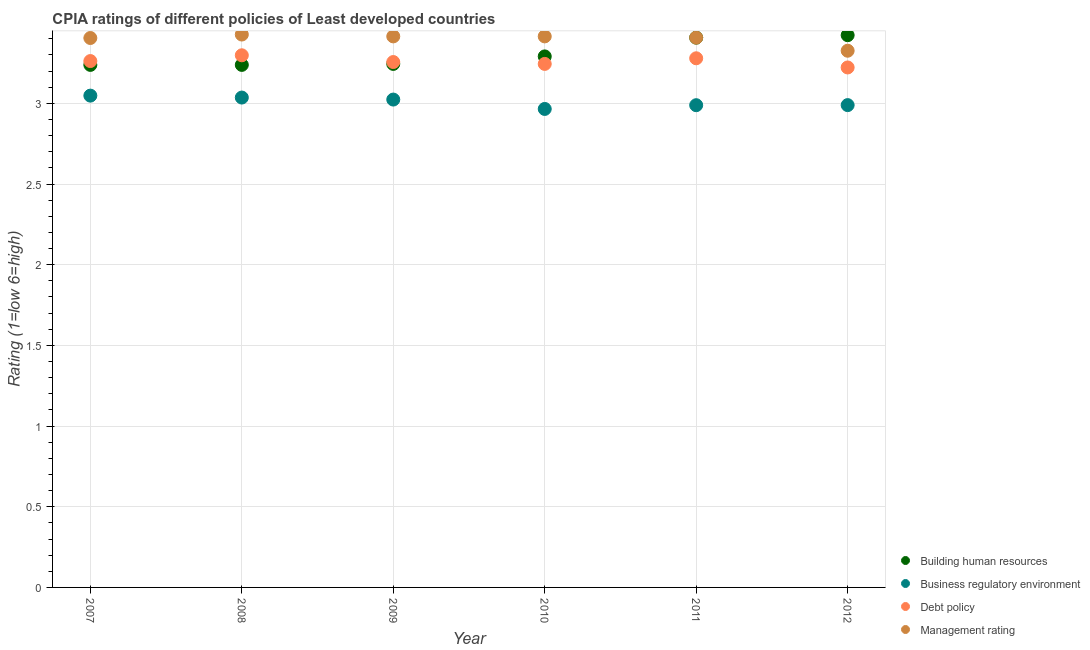How many different coloured dotlines are there?
Your answer should be very brief. 4. Is the number of dotlines equal to the number of legend labels?
Your answer should be compact. Yes. What is the cpia rating of debt policy in 2008?
Offer a very short reply. 3.3. Across all years, what is the maximum cpia rating of management?
Give a very brief answer. 3.43. Across all years, what is the minimum cpia rating of debt policy?
Your answer should be very brief. 3.22. In which year was the cpia rating of business regulatory environment maximum?
Give a very brief answer. 2007. What is the total cpia rating of debt policy in the graph?
Your answer should be compact. 19.56. What is the difference between the cpia rating of debt policy in 2009 and that in 2011?
Offer a very short reply. -0.02. What is the difference between the cpia rating of debt policy in 2007 and the cpia rating of business regulatory environment in 2008?
Your response must be concise. 0.23. What is the average cpia rating of building human resources per year?
Give a very brief answer. 3.31. In the year 2009, what is the difference between the cpia rating of building human resources and cpia rating of debt policy?
Keep it short and to the point. -0.01. What is the ratio of the cpia rating of debt policy in 2007 to that in 2008?
Keep it short and to the point. 0.99. Is the cpia rating of business regulatory environment in 2009 less than that in 2011?
Provide a succinct answer. No. Is the difference between the cpia rating of building human resources in 2008 and 2011 greater than the difference between the cpia rating of management in 2008 and 2011?
Ensure brevity in your answer.  No. What is the difference between the highest and the second highest cpia rating of business regulatory environment?
Ensure brevity in your answer.  0.01. What is the difference between the highest and the lowest cpia rating of building human resources?
Your answer should be compact. 0.18. Is it the case that in every year, the sum of the cpia rating of debt policy and cpia rating of building human resources is greater than the sum of cpia rating of management and cpia rating of business regulatory environment?
Your response must be concise. No. How many dotlines are there?
Make the answer very short. 4. What is the difference between two consecutive major ticks on the Y-axis?
Ensure brevity in your answer.  0.5. Are the values on the major ticks of Y-axis written in scientific E-notation?
Provide a succinct answer. No. How many legend labels are there?
Your answer should be compact. 4. What is the title of the graph?
Give a very brief answer. CPIA ratings of different policies of Least developed countries. Does "Social Assistance" appear as one of the legend labels in the graph?
Make the answer very short. No. What is the label or title of the X-axis?
Give a very brief answer. Year. What is the Rating (1=low 6=high) in Building human resources in 2007?
Ensure brevity in your answer.  3.24. What is the Rating (1=low 6=high) of Business regulatory environment in 2007?
Ensure brevity in your answer.  3.05. What is the Rating (1=low 6=high) of Debt policy in 2007?
Offer a very short reply. 3.26. What is the Rating (1=low 6=high) of Management rating in 2007?
Make the answer very short. 3.4. What is the Rating (1=low 6=high) in Building human resources in 2008?
Make the answer very short. 3.24. What is the Rating (1=low 6=high) of Business regulatory environment in 2008?
Your response must be concise. 3.04. What is the Rating (1=low 6=high) in Debt policy in 2008?
Offer a very short reply. 3.3. What is the Rating (1=low 6=high) in Management rating in 2008?
Offer a very short reply. 3.43. What is the Rating (1=low 6=high) in Building human resources in 2009?
Provide a succinct answer. 3.24. What is the Rating (1=low 6=high) of Business regulatory environment in 2009?
Provide a succinct answer. 3.02. What is the Rating (1=low 6=high) in Debt policy in 2009?
Your response must be concise. 3.26. What is the Rating (1=low 6=high) of Management rating in 2009?
Keep it short and to the point. 3.41. What is the Rating (1=low 6=high) of Building human resources in 2010?
Keep it short and to the point. 3.29. What is the Rating (1=low 6=high) of Business regulatory environment in 2010?
Provide a succinct answer. 2.97. What is the Rating (1=low 6=high) in Debt policy in 2010?
Offer a terse response. 3.24. What is the Rating (1=low 6=high) of Management rating in 2010?
Provide a short and direct response. 3.41. What is the Rating (1=low 6=high) in Building human resources in 2011?
Offer a terse response. 3.41. What is the Rating (1=low 6=high) of Business regulatory environment in 2011?
Your response must be concise. 2.99. What is the Rating (1=low 6=high) of Debt policy in 2011?
Ensure brevity in your answer.  3.28. What is the Rating (1=low 6=high) in Management rating in 2011?
Make the answer very short. 3.41. What is the Rating (1=low 6=high) in Building human resources in 2012?
Your answer should be very brief. 3.42. What is the Rating (1=low 6=high) in Business regulatory environment in 2012?
Your answer should be very brief. 2.99. What is the Rating (1=low 6=high) in Debt policy in 2012?
Keep it short and to the point. 3.22. What is the Rating (1=low 6=high) in Management rating in 2012?
Offer a terse response. 3.33. Across all years, what is the maximum Rating (1=low 6=high) in Building human resources?
Give a very brief answer. 3.42. Across all years, what is the maximum Rating (1=low 6=high) of Business regulatory environment?
Your answer should be very brief. 3.05. Across all years, what is the maximum Rating (1=low 6=high) in Debt policy?
Provide a succinct answer. 3.3. Across all years, what is the maximum Rating (1=low 6=high) in Management rating?
Give a very brief answer. 3.43. Across all years, what is the minimum Rating (1=low 6=high) in Building human resources?
Offer a very short reply. 3.24. Across all years, what is the minimum Rating (1=low 6=high) of Business regulatory environment?
Offer a terse response. 2.97. Across all years, what is the minimum Rating (1=low 6=high) in Debt policy?
Offer a terse response. 3.22. Across all years, what is the minimum Rating (1=low 6=high) of Management rating?
Your answer should be very brief. 3.33. What is the total Rating (1=low 6=high) in Building human resources in the graph?
Offer a terse response. 19.84. What is the total Rating (1=low 6=high) in Business regulatory environment in the graph?
Provide a succinct answer. 18.05. What is the total Rating (1=low 6=high) in Debt policy in the graph?
Offer a very short reply. 19.56. What is the total Rating (1=low 6=high) of Management rating in the graph?
Give a very brief answer. 20.39. What is the difference between the Rating (1=low 6=high) in Business regulatory environment in 2007 and that in 2008?
Your response must be concise. 0.01. What is the difference between the Rating (1=low 6=high) of Debt policy in 2007 and that in 2008?
Your answer should be very brief. -0.04. What is the difference between the Rating (1=low 6=high) in Management rating in 2007 and that in 2008?
Offer a very short reply. -0.02. What is the difference between the Rating (1=low 6=high) of Building human resources in 2007 and that in 2009?
Ensure brevity in your answer.  -0.01. What is the difference between the Rating (1=low 6=high) of Business regulatory environment in 2007 and that in 2009?
Offer a very short reply. 0.02. What is the difference between the Rating (1=low 6=high) in Debt policy in 2007 and that in 2009?
Make the answer very short. 0.01. What is the difference between the Rating (1=low 6=high) in Management rating in 2007 and that in 2009?
Make the answer very short. -0.01. What is the difference between the Rating (1=low 6=high) in Building human resources in 2007 and that in 2010?
Ensure brevity in your answer.  -0.05. What is the difference between the Rating (1=low 6=high) in Business regulatory environment in 2007 and that in 2010?
Make the answer very short. 0.08. What is the difference between the Rating (1=low 6=high) in Debt policy in 2007 and that in 2010?
Give a very brief answer. 0.02. What is the difference between the Rating (1=low 6=high) of Management rating in 2007 and that in 2010?
Provide a short and direct response. -0.01. What is the difference between the Rating (1=low 6=high) of Building human resources in 2007 and that in 2011?
Your answer should be very brief. -0.17. What is the difference between the Rating (1=low 6=high) of Business regulatory environment in 2007 and that in 2011?
Provide a short and direct response. 0.06. What is the difference between the Rating (1=low 6=high) of Debt policy in 2007 and that in 2011?
Provide a succinct answer. -0.02. What is the difference between the Rating (1=low 6=high) in Management rating in 2007 and that in 2011?
Provide a short and direct response. -0. What is the difference between the Rating (1=low 6=high) in Building human resources in 2007 and that in 2012?
Offer a terse response. -0.18. What is the difference between the Rating (1=low 6=high) in Business regulatory environment in 2007 and that in 2012?
Offer a terse response. 0.06. What is the difference between the Rating (1=low 6=high) in Debt policy in 2007 and that in 2012?
Provide a succinct answer. 0.04. What is the difference between the Rating (1=low 6=high) in Management rating in 2007 and that in 2012?
Ensure brevity in your answer.  0.08. What is the difference between the Rating (1=low 6=high) in Building human resources in 2008 and that in 2009?
Your response must be concise. -0.01. What is the difference between the Rating (1=low 6=high) of Business regulatory environment in 2008 and that in 2009?
Your response must be concise. 0.01. What is the difference between the Rating (1=low 6=high) in Debt policy in 2008 and that in 2009?
Offer a terse response. 0.04. What is the difference between the Rating (1=low 6=high) of Management rating in 2008 and that in 2009?
Your answer should be compact. 0.01. What is the difference between the Rating (1=low 6=high) of Building human resources in 2008 and that in 2010?
Your response must be concise. -0.05. What is the difference between the Rating (1=low 6=high) of Business regulatory environment in 2008 and that in 2010?
Your answer should be compact. 0.07. What is the difference between the Rating (1=low 6=high) in Debt policy in 2008 and that in 2010?
Give a very brief answer. 0.05. What is the difference between the Rating (1=low 6=high) of Management rating in 2008 and that in 2010?
Your answer should be compact. 0.01. What is the difference between the Rating (1=low 6=high) in Building human resources in 2008 and that in 2011?
Give a very brief answer. -0.17. What is the difference between the Rating (1=low 6=high) in Business regulatory environment in 2008 and that in 2011?
Your answer should be very brief. 0.05. What is the difference between the Rating (1=low 6=high) of Debt policy in 2008 and that in 2011?
Keep it short and to the point. 0.02. What is the difference between the Rating (1=low 6=high) in Management rating in 2008 and that in 2011?
Provide a short and direct response. 0.02. What is the difference between the Rating (1=low 6=high) in Building human resources in 2008 and that in 2012?
Provide a short and direct response. -0.18. What is the difference between the Rating (1=low 6=high) in Business regulatory environment in 2008 and that in 2012?
Give a very brief answer. 0.05. What is the difference between the Rating (1=low 6=high) of Debt policy in 2008 and that in 2012?
Offer a very short reply. 0.08. What is the difference between the Rating (1=low 6=high) in Management rating in 2008 and that in 2012?
Provide a succinct answer. 0.1. What is the difference between the Rating (1=low 6=high) of Building human resources in 2009 and that in 2010?
Your answer should be compact. -0.05. What is the difference between the Rating (1=low 6=high) of Business regulatory environment in 2009 and that in 2010?
Provide a short and direct response. 0.06. What is the difference between the Rating (1=low 6=high) in Debt policy in 2009 and that in 2010?
Provide a succinct answer. 0.01. What is the difference between the Rating (1=low 6=high) of Management rating in 2009 and that in 2010?
Offer a very short reply. 0. What is the difference between the Rating (1=low 6=high) of Building human resources in 2009 and that in 2011?
Offer a terse response. -0.16. What is the difference between the Rating (1=low 6=high) of Business regulatory environment in 2009 and that in 2011?
Ensure brevity in your answer.  0.03. What is the difference between the Rating (1=low 6=high) in Debt policy in 2009 and that in 2011?
Your response must be concise. -0.02. What is the difference between the Rating (1=low 6=high) in Management rating in 2009 and that in 2011?
Ensure brevity in your answer.  0.01. What is the difference between the Rating (1=low 6=high) of Building human resources in 2009 and that in 2012?
Ensure brevity in your answer.  -0.18. What is the difference between the Rating (1=low 6=high) in Business regulatory environment in 2009 and that in 2012?
Give a very brief answer. 0.03. What is the difference between the Rating (1=low 6=high) in Debt policy in 2009 and that in 2012?
Provide a succinct answer. 0.03. What is the difference between the Rating (1=low 6=high) of Management rating in 2009 and that in 2012?
Offer a very short reply. 0.09. What is the difference between the Rating (1=low 6=high) in Building human resources in 2010 and that in 2011?
Provide a short and direct response. -0.12. What is the difference between the Rating (1=low 6=high) in Business regulatory environment in 2010 and that in 2011?
Your answer should be compact. -0.02. What is the difference between the Rating (1=low 6=high) of Debt policy in 2010 and that in 2011?
Make the answer very short. -0.03. What is the difference between the Rating (1=low 6=high) of Management rating in 2010 and that in 2011?
Offer a very short reply. 0.01. What is the difference between the Rating (1=low 6=high) in Building human resources in 2010 and that in 2012?
Give a very brief answer. -0.13. What is the difference between the Rating (1=low 6=high) in Business regulatory environment in 2010 and that in 2012?
Keep it short and to the point. -0.02. What is the difference between the Rating (1=low 6=high) of Debt policy in 2010 and that in 2012?
Provide a short and direct response. 0.02. What is the difference between the Rating (1=low 6=high) in Management rating in 2010 and that in 2012?
Make the answer very short. 0.09. What is the difference between the Rating (1=low 6=high) of Building human resources in 2011 and that in 2012?
Give a very brief answer. -0.02. What is the difference between the Rating (1=low 6=high) in Business regulatory environment in 2011 and that in 2012?
Ensure brevity in your answer.  -0. What is the difference between the Rating (1=low 6=high) of Debt policy in 2011 and that in 2012?
Your answer should be compact. 0.06. What is the difference between the Rating (1=low 6=high) in Management rating in 2011 and that in 2012?
Keep it short and to the point. 0.08. What is the difference between the Rating (1=low 6=high) of Building human resources in 2007 and the Rating (1=low 6=high) of Business regulatory environment in 2008?
Your answer should be very brief. 0.2. What is the difference between the Rating (1=low 6=high) in Building human resources in 2007 and the Rating (1=low 6=high) in Debt policy in 2008?
Offer a terse response. -0.06. What is the difference between the Rating (1=low 6=high) of Building human resources in 2007 and the Rating (1=low 6=high) of Management rating in 2008?
Offer a very short reply. -0.19. What is the difference between the Rating (1=low 6=high) in Business regulatory environment in 2007 and the Rating (1=low 6=high) in Management rating in 2008?
Your response must be concise. -0.38. What is the difference between the Rating (1=low 6=high) in Debt policy in 2007 and the Rating (1=low 6=high) in Management rating in 2008?
Make the answer very short. -0.16. What is the difference between the Rating (1=low 6=high) of Building human resources in 2007 and the Rating (1=low 6=high) of Business regulatory environment in 2009?
Keep it short and to the point. 0.21. What is the difference between the Rating (1=low 6=high) of Building human resources in 2007 and the Rating (1=low 6=high) of Debt policy in 2009?
Offer a very short reply. -0.02. What is the difference between the Rating (1=low 6=high) of Building human resources in 2007 and the Rating (1=low 6=high) of Management rating in 2009?
Give a very brief answer. -0.18. What is the difference between the Rating (1=low 6=high) of Business regulatory environment in 2007 and the Rating (1=low 6=high) of Debt policy in 2009?
Offer a terse response. -0.21. What is the difference between the Rating (1=low 6=high) in Business regulatory environment in 2007 and the Rating (1=low 6=high) in Management rating in 2009?
Make the answer very short. -0.37. What is the difference between the Rating (1=low 6=high) in Debt policy in 2007 and the Rating (1=low 6=high) in Management rating in 2009?
Ensure brevity in your answer.  -0.15. What is the difference between the Rating (1=low 6=high) in Building human resources in 2007 and the Rating (1=low 6=high) in Business regulatory environment in 2010?
Offer a terse response. 0.27. What is the difference between the Rating (1=low 6=high) in Building human resources in 2007 and the Rating (1=low 6=high) in Debt policy in 2010?
Give a very brief answer. -0.01. What is the difference between the Rating (1=low 6=high) in Building human resources in 2007 and the Rating (1=low 6=high) in Management rating in 2010?
Offer a very short reply. -0.18. What is the difference between the Rating (1=low 6=high) in Business regulatory environment in 2007 and the Rating (1=low 6=high) in Debt policy in 2010?
Make the answer very short. -0.2. What is the difference between the Rating (1=low 6=high) in Business regulatory environment in 2007 and the Rating (1=low 6=high) in Management rating in 2010?
Make the answer very short. -0.37. What is the difference between the Rating (1=low 6=high) of Debt policy in 2007 and the Rating (1=low 6=high) of Management rating in 2010?
Offer a very short reply. -0.15. What is the difference between the Rating (1=low 6=high) of Building human resources in 2007 and the Rating (1=low 6=high) of Business regulatory environment in 2011?
Your answer should be very brief. 0.25. What is the difference between the Rating (1=low 6=high) in Building human resources in 2007 and the Rating (1=low 6=high) in Debt policy in 2011?
Your answer should be very brief. -0.04. What is the difference between the Rating (1=low 6=high) of Building human resources in 2007 and the Rating (1=low 6=high) of Management rating in 2011?
Provide a succinct answer. -0.17. What is the difference between the Rating (1=low 6=high) in Business regulatory environment in 2007 and the Rating (1=low 6=high) in Debt policy in 2011?
Your response must be concise. -0.23. What is the difference between the Rating (1=low 6=high) in Business regulatory environment in 2007 and the Rating (1=low 6=high) in Management rating in 2011?
Give a very brief answer. -0.36. What is the difference between the Rating (1=low 6=high) in Debt policy in 2007 and the Rating (1=low 6=high) in Management rating in 2011?
Provide a short and direct response. -0.15. What is the difference between the Rating (1=low 6=high) in Building human resources in 2007 and the Rating (1=low 6=high) in Business regulatory environment in 2012?
Keep it short and to the point. 0.25. What is the difference between the Rating (1=low 6=high) in Building human resources in 2007 and the Rating (1=low 6=high) in Debt policy in 2012?
Your answer should be very brief. 0.02. What is the difference between the Rating (1=low 6=high) of Building human resources in 2007 and the Rating (1=low 6=high) of Management rating in 2012?
Your response must be concise. -0.09. What is the difference between the Rating (1=low 6=high) of Business regulatory environment in 2007 and the Rating (1=low 6=high) of Debt policy in 2012?
Your answer should be compact. -0.17. What is the difference between the Rating (1=low 6=high) in Business regulatory environment in 2007 and the Rating (1=low 6=high) in Management rating in 2012?
Make the answer very short. -0.28. What is the difference between the Rating (1=low 6=high) in Debt policy in 2007 and the Rating (1=low 6=high) in Management rating in 2012?
Make the answer very short. -0.06. What is the difference between the Rating (1=low 6=high) in Building human resources in 2008 and the Rating (1=low 6=high) in Business regulatory environment in 2009?
Provide a short and direct response. 0.21. What is the difference between the Rating (1=low 6=high) of Building human resources in 2008 and the Rating (1=low 6=high) of Debt policy in 2009?
Offer a very short reply. -0.02. What is the difference between the Rating (1=low 6=high) in Building human resources in 2008 and the Rating (1=low 6=high) in Management rating in 2009?
Provide a short and direct response. -0.18. What is the difference between the Rating (1=low 6=high) in Business regulatory environment in 2008 and the Rating (1=low 6=high) in Debt policy in 2009?
Ensure brevity in your answer.  -0.22. What is the difference between the Rating (1=low 6=high) of Business regulatory environment in 2008 and the Rating (1=low 6=high) of Management rating in 2009?
Offer a very short reply. -0.38. What is the difference between the Rating (1=low 6=high) in Debt policy in 2008 and the Rating (1=low 6=high) in Management rating in 2009?
Ensure brevity in your answer.  -0.12. What is the difference between the Rating (1=low 6=high) of Building human resources in 2008 and the Rating (1=low 6=high) of Business regulatory environment in 2010?
Provide a short and direct response. 0.27. What is the difference between the Rating (1=low 6=high) in Building human resources in 2008 and the Rating (1=low 6=high) in Debt policy in 2010?
Make the answer very short. -0.01. What is the difference between the Rating (1=low 6=high) of Building human resources in 2008 and the Rating (1=low 6=high) of Management rating in 2010?
Your answer should be very brief. -0.18. What is the difference between the Rating (1=low 6=high) in Business regulatory environment in 2008 and the Rating (1=low 6=high) in Debt policy in 2010?
Keep it short and to the point. -0.21. What is the difference between the Rating (1=low 6=high) in Business regulatory environment in 2008 and the Rating (1=low 6=high) in Management rating in 2010?
Give a very brief answer. -0.38. What is the difference between the Rating (1=low 6=high) of Debt policy in 2008 and the Rating (1=low 6=high) of Management rating in 2010?
Provide a succinct answer. -0.12. What is the difference between the Rating (1=low 6=high) in Building human resources in 2008 and the Rating (1=low 6=high) in Business regulatory environment in 2011?
Provide a short and direct response. 0.25. What is the difference between the Rating (1=low 6=high) in Building human resources in 2008 and the Rating (1=low 6=high) in Debt policy in 2011?
Provide a short and direct response. -0.04. What is the difference between the Rating (1=low 6=high) of Building human resources in 2008 and the Rating (1=low 6=high) of Management rating in 2011?
Your response must be concise. -0.17. What is the difference between the Rating (1=low 6=high) in Business regulatory environment in 2008 and the Rating (1=low 6=high) in Debt policy in 2011?
Give a very brief answer. -0.24. What is the difference between the Rating (1=low 6=high) of Business regulatory environment in 2008 and the Rating (1=low 6=high) of Management rating in 2011?
Your answer should be very brief. -0.37. What is the difference between the Rating (1=low 6=high) of Debt policy in 2008 and the Rating (1=low 6=high) of Management rating in 2011?
Your response must be concise. -0.11. What is the difference between the Rating (1=low 6=high) of Building human resources in 2008 and the Rating (1=low 6=high) of Business regulatory environment in 2012?
Your response must be concise. 0.25. What is the difference between the Rating (1=low 6=high) in Building human resources in 2008 and the Rating (1=low 6=high) in Debt policy in 2012?
Provide a short and direct response. 0.02. What is the difference between the Rating (1=low 6=high) in Building human resources in 2008 and the Rating (1=low 6=high) in Management rating in 2012?
Give a very brief answer. -0.09. What is the difference between the Rating (1=low 6=high) of Business regulatory environment in 2008 and the Rating (1=low 6=high) of Debt policy in 2012?
Give a very brief answer. -0.19. What is the difference between the Rating (1=low 6=high) of Business regulatory environment in 2008 and the Rating (1=low 6=high) of Management rating in 2012?
Ensure brevity in your answer.  -0.29. What is the difference between the Rating (1=low 6=high) of Debt policy in 2008 and the Rating (1=low 6=high) of Management rating in 2012?
Offer a terse response. -0.03. What is the difference between the Rating (1=low 6=high) in Building human resources in 2009 and the Rating (1=low 6=high) in Business regulatory environment in 2010?
Provide a short and direct response. 0.28. What is the difference between the Rating (1=low 6=high) in Building human resources in 2009 and the Rating (1=low 6=high) in Management rating in 2010?
Offer a terse response. -0.17. What is the difference between the Rating (1=low 6=high) in Business regulatory environment in 2009 and the Rating (1=low 6=high) in Debt policy in 2010?
Provide a succinct answer. -0.22. What is the difference between the Rating (1=low 6=high) in Business regulatory environment in 2009 and the Rating (1=low 6=high) in Management rating in 2010?
Your answer should be compact. -0.39. What is the difference between the Rating (1=low 6=high) of Debt policy in 2009 and the Rating (1=low 6=high) of Management rating in 2010?
Your answer should be compact. -0.16. What is the difference between the Rating (1=low 6=high) in Building human resources in 2009 and the Rating (1=low 6=high) in Business regulatory environment in 2011?
Your answer should be very brief. 0.26. What is the difference between the Rating (1=low 6=high) in Building human resources in 2009 and the Rating (1=low 6=high) in Debt policy in 2011?
Your answer should be compact. -0.03. What is the difference between the Rating (1=low 6=high) of Building human resources in 2009 and the Rating (1=low 6=high) of Management rating in 2011?
Give a very brief answer. -0.16. What is the difference between the Rating (1=low 6=high) in Business regulatory environment in 2009 and the Rating (1=low 6=high) in Debt policy in 2011?
Provide a short and direct response. -0.26. What is the difference between the Rating (1=low 6=high) in Business regulatory environment in 2009 and the Rating (1=low 6=high) in Management rating in 2011?
Make the answer very short. -0.38. What is the difference between the Rating (1=low 6=high) of Debt policy in 2009 and the Rating (1=low 6=high) of Management rating in 2011?
Your answer should be very brief. -0.15. What is the difference between the Rating (1=low 6=high) of Building human resources in 2009 and the Rating (1=low 6=high) of Business regulatory environment in 2012?
Make the answer very short. 0.26. What is the difference between the Rating (1=low 6=high) of Building human resources in 2009 and the Rating (1=low 6=high) of Debt policy in 2012?
Offer a terse response. 0.02. What is the difference between the Rating (1=low 6=high) of Building human resources in 2009 and the Rating (1=low 6=high) of Management rating in 2012?
Give a very brief answer. -0.08. What is the difference between the Rating (1=low 6=high) in Business regulatory environment in 2009 and the Rating (1=low 6=high) in Debt policy in 2012?
Offer a very short reply. -0.2. What is the difference between the Rating (1=low 6=high) in Business regulatory environment in 2009 and the Rating (1=low 6=high) in Management rating in 2012?
Your answer should be compact. -0.3. What is the difference between the Rating (1=low 6=high) of Debt policy in 2009 and the Rating (1=low 6=high) of Management rating in 2012?
Your answer should be compact. -0.07. What is the difference between the Rating (1=low 6=high) of Building human resources in 2010 and the Rating (1=low 6=high) of Business regulatory environment in 2011?
Make the answer very short. 0.3. What is the difference between the Rating (1=low 6=high) of Building human resources in 2010 and the Rating (1=low 6=high) of Debt policy in 2011?
Your answer should be compact. 0.01. What is the difference between the Rating (1=low 6=high) of Building human resources in 2010 and the Rating (1=low 6=high) of Management rating in 2011?
Keep it short and to the point. -0.12. What is the difference between the Rating (1=low 6=high) in Business regulatory environment in 2010 and the Rating (1=low 6=high) in Debt policy in 2011?
Give a very brief answer. -0.31. What is the difference between the Rating (1=low 6=high) of Business regulatory environment in 2010 and the Rating (1=low 6=high) of Management rating in 2011?
Offer a terse response. -0.44. What is the difference between the Rating (1=low 6=high) of Debt policy in 2010 and the Rating (1=low 6=high) of Management rating in 2011?
Your response must be concise. -0.16. What is the difference between the Rating (1=low 6=high) in Building human resources in 2010 and the Rating (1=low 6=high) in Business regulatory environment in 2012?
Make the answer very short. 0.3. What is the difference between the Rating (1=low 6=high) in Building human resources in 2010 and the Rating (1=low 6=high) in Debt policy in 2012?
Offer a terse response. 0.07. What is the difference between the Rating (1=low 6=high) of Building human resources in 2010 and the Rating (1=low 6=high) of Management rating in 2012?
Your response must be concise. -0.04. What is the difference between the Rating (1=low 6=high) in Business regulatory environment in 2010 and the Rating (1=low 6=high) in Debt policy in 2012?
Give a very brief answer. -0.26. What is the difference between the Rating (1=low 6=high) of Business regulatory environment in 2010 and the Rating (1=low 6=high) of Management rating in 2012?
Offer a terse response. -0.36. What is the difference between the Rating (1=low 6=high) of Debt policy in 2010 and the Rating (1=low 6=high) of Management rating in 2012?
Keep it short and to the point. -0.08. What is the difference between the Rating (1=low 6=high) in Building human resources in 2011 and the Rating (1=low 6=high) in Business regulatory environment in 2012?
Provide a succinct answer. 0.42. What is the difference between the Rating (1=low 6=high) in Building human resources in 2011 and the Rating (1=low 6=high) in Debt policy in 2012?
Offer a very short reply. 0.18. What is the difference between the Rating (1=low 6=high) of Building human resources in 2011 and the Rating (1=low 6=high) of Management rating in 2012?
Ensure brevity in your answer.  0.08. What is the difference between the Rating (1=low 6=high) of Business regulatory environment in 2011 and the Rating (1=low 6=high) of Debt policy in 2012?
Ensure brevity in your answer.  -0.23. What is the difference between the Rating (1=low 6=high) in Business regulatory environment in 2011 and the Rating (1=low 6=high) in Management rating in 2012?
Your answer should be compact. -0.34. What is the difference between the Rating (1=low 6=high) of Debt policy in 2011 and the Rating (1=low 6=high) of Management rating in 2012?
Keep it short and to the point. -0.05. What is the average Rating (1=low 6=high) of Building human resources per year?
Provide a succinct answer. 3.31. What is the average Rating (1=low 6=high) in Business regulatory environment per year?
Make the answer very short. 3.01. What is the average Rating (1=low 6=high) in Debt policy per year?
Ensure brevity in your answer.  3.26. What is the average Rating (1=low 6=high) in Management rating per year?
Ensure brevity in your answer.  3.4. In the year 2007, what is the difference between the Rating (1=low 6=high) in Building human resources and Rating (1=low 6=high) in Business regulatory environment?
Keep it short and to the point. 0.19. In the year 2007, what is the difference between the Rating (1=low 6=high) of Building human resources and Rating (1=low 6=high) of Debt policy?
Your answer should be very brief. -0.02. In the year 2007, what is the difference between the Rating (1=low 6=high) of Building human resources and Rating (1=low 6=high) of Management rating?
Give a very brief answer. -0.17. In the year 2007, what is the difference between the Rating (1=low 6=high) of Business regulatory environment and Rating (1=low 6=high) of Debt policy?
Provide a succinct answer. -0.21. In the year 2007, what is the difference between the Rating (1=low 6=high) of Business regulatory environment and Rating (1=low 6=high) of Management rating?
Offer a terse response. -0.36. In the year 2007, what is the difference between the Rating (1=low 6=high) of Debt policy and Rating (1=low 6=high) of Management rating?
Keep it short and to the point. -0.14. In the year 2008, what is the difference between the Rating (1=low 6=high) of Building human resources and Rating (1=low 6=high) of Business regulatory environment?
Offer a very short reply. 0.2. In the year 2008, what is the difference between the Rating (1=low 6=high) in Building human resources and Rating (1=low 6=high) in Debt policy?
Make the answer very short. -0.06. In the year 2008, what is the difference between the Rating (1=low 6=high) of Building human resources and Rating (1=low 6=high) of Management rating?
Offer a very short reply. -0.19. In the year 2008, what is the difference between the Rating (1=low 6=high) in Business regulatory environment and Rating (1=low 6=high) in Debt policy?
Make the answer very short. -0.26. In the year 2008, what is the difference between the Rating (1=low 6=high) in Business regulatory environment and Rating (1=low 6=high) in Management rating?
Your response must be concise. -0.39. In the year 2008, what is the difference between the Rating (1=low 6=high) in Debt policy and Rating (1=low 6=high) in Management rating?
Provide a short and direct response. -0.13. In the year 2009, what is the difference between the Rating (1=low 6=high) in Building human resources and Rating (1=low 6=high) in Business regulatory environment?
Offer a very short reply. 0.22. In the year 2009, what is the difference between the Rating (1=low 6=high) in Building human resources and Rating (1=low 6=high) in Debt policy?
Give a very brief answer. -0.01. In the year 2009, what is the difference between the Rating (1=low 6=high) of Building human resources and Rating (1=low 6=high) of Management rating?
Offer a very short reply. -0.17. In the year 2009, what is the difference between the Rating (1=low 6=high) of Business regulatory environment and Rating (1=low 6=high) of Debt policy?
Provide a short and direct response. -0.23. In the year 2009, what is the difference between the Rating (1=low 6=high) of Business regulatory environment and Rating (1=low 6=high) of Management rating?
Keep it short and to the point. -0.39. In the year 2009, what is the difference between the Rating (1=low 6=high) of Debt policy and Rating (1=low 6=high) of Management rating?
Your response must be concise. -0.16. In the year 2010, what is the difference between the Rating (1=low 6=high) in Building human resources and Rating (1=low 6=high) in Business regulatory environment?
Your response must be concise. 0.33. In the year 2010, what is the difference between the Rating (1=low 6=high) of Building human resources and Rating (1=low 6=high) of Debt policy?
Your response must be concise. 0.05. In the year 2010, what is the difference between the Rating (1=low 6=high) of Building human resources and Rating (1=low 6=high) of Management rating?
Keep it short and to the point. -0.12. In the year 2010, what is the difference between the Rating (1=low 6=high) of Business regulatory environment and Rating (1=low 6=high) of Debt policy?
Make the answer very short. -0.28. In the year 2010, what is the difference between the Rating (1=low 6=high) in Business regulatory environment and Rating (1=low 6=high) in Management rating?
Provide a short and direct response. -0.45. In the year 2010, what is the difference between the Rating (1=low 6=high) in Debt policy and Rating (1=low 6=high) in Management rating?
Offer a terse response. -0.17. In the year 2011, what is the difference between the Rating (1=low 6=high) of Building human resources and Rating (1=low 6=high) of Business regulatory environment?
Make the answer very short. 0.42. In the year 2011, what is the difference between the Rating (1=low 6=high) of Building human resources and Rating (1=low 6=high) of Debt policy?
Your response must be concise. 0.13. In the year 2011, what is the difference between the Rating (1=low 6=high) in Building human resources and Rating (1=low 6=high) in Management rating?
Provide a succinct answer. 0. In the year 2011, what is the difference between the Rating (1=low 6=high) in Business regulatory environment and Rating (1=low 6=high) in Debt policy?
Keep it short and to the point. -0.29. In the year 2011, what is the difference between the Rating (1=low 6=high) of Business regulatory environment and Rating (1=low 6=high) of Management rating?
Offer a very short reply. -0.42. In the year 2011, what is the difference between the Rating (1=low 6=high) of Debt policy and Rating (1=low 6=high) of Management rating?
Make the answer very short. -0.13. In the year 2012, what is the difference between the Rating (1=low 6=high) in Building human resources and Rating (1=low 6=high) in Business regulatory environment?
Ensure brevity in your answer.  0.43. In the year 2012, what is the difference between the Rating (1=low 6=high) of Building human resources and Rating (1=low 6=high) of Debt policy?
Ensure brevity in your answer.  0.2. In the year 2012, what is the difference between the Rating (1=low 6=high) in Building human resources and Rating (1=low 6=high) in Management rating?
Offer a terse response. 0.1. In the year 2012, what is the difference between the Rating (1=low 6=high) in Business regulatory environment and Rating (1=low 6=high) in Debt policy?
Offer a very short reply. -0.23. In the year 2012, what is the difference between the Rating (1=low 6=high) in Business regulatory environment and Rating (1=low 6=high) in Management rating?
Keep it short and to the point. -0.34. In the year 2012, what is the difference between the Rating (1=low 6=high) of Debt policy and Rating (1=low 6=high) of Management rating?
Make the answer very short. -0.1. What is the ratio of the Rating (1=low 6=high) of Business regulatory environment in 2007 to that in 2008?
Give a very brief answer. 1. What is the ratio of the Rating (1=low 6=high) of Debt policy in 2007 to that in 2008?
Your response must be concise. 0.99. What is the ratio of the Rating (1=low 6=high) of Business regulatory environment in 2007 to that in 2009?
Give a very brief answer. 1.01. What is the ratio of the Rating (1=low 6=high) in Debt policy in 2007 to that in 2009?
Your answer should be very brief. 1. What is the ratio of the Rating (1=low 6=high) in Management rating in 2007 to that in 2009?
Ensure brevity in your answer.  1. What is the ratio of the Rating (1=low 6=high) of Business regulatory environment in 2007 to that in 2010?
Provide a short and direct response. 1.03. What is the ratio of the Rating (1=low 6=high) of Debt policy in 2007 to that in 2010?
Your answer should be very brief. 1.01. What is the ratio of the Rating (1=low 6=high) in Building human resources in 2007 to that in 2011?
Make the answer very short. 0.95. What is the ratio of the Rating (1=low 6=high) in Business regulatory environment in 2007 to that in 2011?
Make the answer very short. 1.02. What is the ratio of the Rating (1=low 6=high) in Debt policy in 2007 to that in 2011?
Give a very brief answer. 0.99. What is the ratio of the Rating (1=low 6=high) of Building human resources in 2007 to that in 2012?
Provide a succinct answer. 0.95. What is the ratio of the Rating (1=low 6=high) in Business regulatory environment in 2007 to that in 2012?
Your answer should be very brief. 1.02. What is the ratio of the Rating (1=low 6=high) of Debt policy in 2007 to that in 2012?
Ensure brevity in your answer.  1.01. What is the ratio of the Rating (1=low 6=high) in Management rating in 2007 to that in 2012?
Give a very brief answer. 1.02. What is the ratio of the Rating (1=low 6=high) of Building human resources in 2008 to that in 2009?
Your answer should be compact. 1. What is the ratio of the Rating (1=low 6=high) in Debt policy in 2008 to that in 2009?
Offer a very short reply. 1.01. What is the ratio of the Rating (1=low 6=high) in Management rating in 2008 to that in 2009?
Offer a very short reply. 1. What is the ratio of the Rating (1=low 6=high) of Business regulatory environment in 2008 to that in 2010?
Keep it short and to the point. 1.02. What is the ratio of the Rating (1=low 6=high) in Debt policy in 2008 to that in 2010?
Offer a very short reply. 1.02. What is the ratio of the Rating (1=low 6=high) of Management rating in 2008 to that in 2010?
Your answer should be very brief. 1. What is the ratio of the Rating (1=low 6=high) in Building human resources in 2008 to that in 2011?
Offer a very short reply. 0.95. What is the ratio of the Rating (1=low 6=high) in Business regulatory environment in 2008 to that in 2011?
Provide a succinct answer. 1.02. What is the ratio of the Rating (1=low 6=high) in Debt policy in 2008 to that in 2011?
Ensure brevity in your answer.  1.01. What is the ratio of the Rating (1=low 6=high) of Management rating in 2008 to that in 2011?
Offer a very short reply. 1.01. What is the ratio of the Rating (1=low 6=high) of Building human resources in 2008 to that in 2012?
Make the answer very short. 0.95. What is the ratio of the Rating (1=low 6=high) in Business regulatory environment in 2008 to that in 2012?
Provide a succinct answer. 1.02. What is the ratio of the Rating (1=low 6=high) of Debt policy in 2008 to that in 2012?
Your answer should be very brief. 1.02. What is the ratio of the Rating (1=low 6=high) of Management rating in 2008 to that in 2012?
Make the answer very short. 1.03. What is the ratio of the Rating (1=low 6=high) in Building human resources in 2009 to that in 2010?
Provide a short and direct response. 0.99. What is the ratio of the Rating (1=low 6=high) of Business regulatory environment in 2009 to that in 2010?
Provide a succinct answer. 1.02. What is the ratio of the Rating (1=low 6=high) in Building human resources in 2009 to that in 2011?
Your response must be concise. 0.95. What is the ratio of the Rating (1=low 6=high) in Business regulatory environment in 2009 to that in 2011?
Your answer should be very brief. 1.01. What is the ratio of the Rating (1=low 6=high) in Debt policy in 2009 to that in 2011?
Your answer should be very brief. 0.99. What is the ratio of the Rating (1=low 6=high) of Building human resources in 2009 to that in 2012?
Make the answer very short. 0.95. What is the ratio of the Rating (1=low 6=high) in Business regulatory environment in 2009 to that in 2012?
Provide a succinct answer. 1.01. What is the ratio of the Rating (1=low 6=high) in Debt policy in 2009 to that in 2012?
Provide a short and direct response. 1.01. What is the ratio of the Rating (1=low 6=high) of Management rating in 2009 to that in 2012?
Make the answer very short. 1.03. What is the ratio of the Rating (1=low 6=high) of Building human resources in 2010 to that in 2011?
Keep it short and to the point. 0.97. What is the ratio of the Rating (1=low 6=high) of Business regulatory environment in 2010 to that in 2011?
Offer a terse response. 0.99. What is the ratio of the Rating (1=low 6=high) of Debt policy in 2010 to that in 2011?
Ensure brevity in your answer.  0.99. What is the ratio of the Rating (1=low 6=high) of Building human resources in 2010 to that in 2012?
Your response must be concise. 0.96. What is the ratio of the Rating (1=low 6=high) in Debt policy in 2010 to that in 2012?
Ensure brevity in your answer.  1.01. What is the ratio of the Rating (1=low 6=high) in Management rating in 2010 to that in 2012?
Offer a terse response. 1.03. What is the ratio of the Rating (1=low 6=high) of Business regulatory environment in 2011 to that in 2012?
Give a very brief answer. 1. What is the ratio of the Rating (1=low 6=high) of Debt policy in 2011 to that in 2012?
Offer a very short reply. 1.02. What is the ratio of the Rating (1=low 6=high) in Management rating in 2011 to that in 2012?
Offer a very short reply. 1.02. What is the difference between the highest and the second highest Rating (1=low 6=high) of Building human resources?
Provide a short and direct response. 0.02. What is the difference between the highest and the second highest Rating (1=low 6=high) of Business regulatory environment?
Your answer should be very brief. 0.01. What is the difference between the highest and the second highest Rating (1=low 6=high) of Debt policy?
Your answer should be compact. 0.02. What is the difference between the highest and the second highest Rating (1=low 6=high) in Management rating?
Make the answer very short. 0.01. What is the difference between the highest and the lowest Rating (1=low 6=high) in Building human resources?
Your response must be concise. 0.18. What is the difference between the highest and the lowest Rating (1=low 6=high) in Business regulatory environment?
Give a very brief answer. 0.08. What is the difference between the highest and the lowest Rating (1=low 6=high) in Debt policy?
Offer a terse response. 0.08. What is the difference between the highest and the lowest Rating (1=low 6=high) in Management rating?
Your answer should be compact. 0.1. 